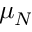Convert formula to latex. <formula><loc_0><loc_0><loc_500><loc_500>\mu _ { N }</formula> 